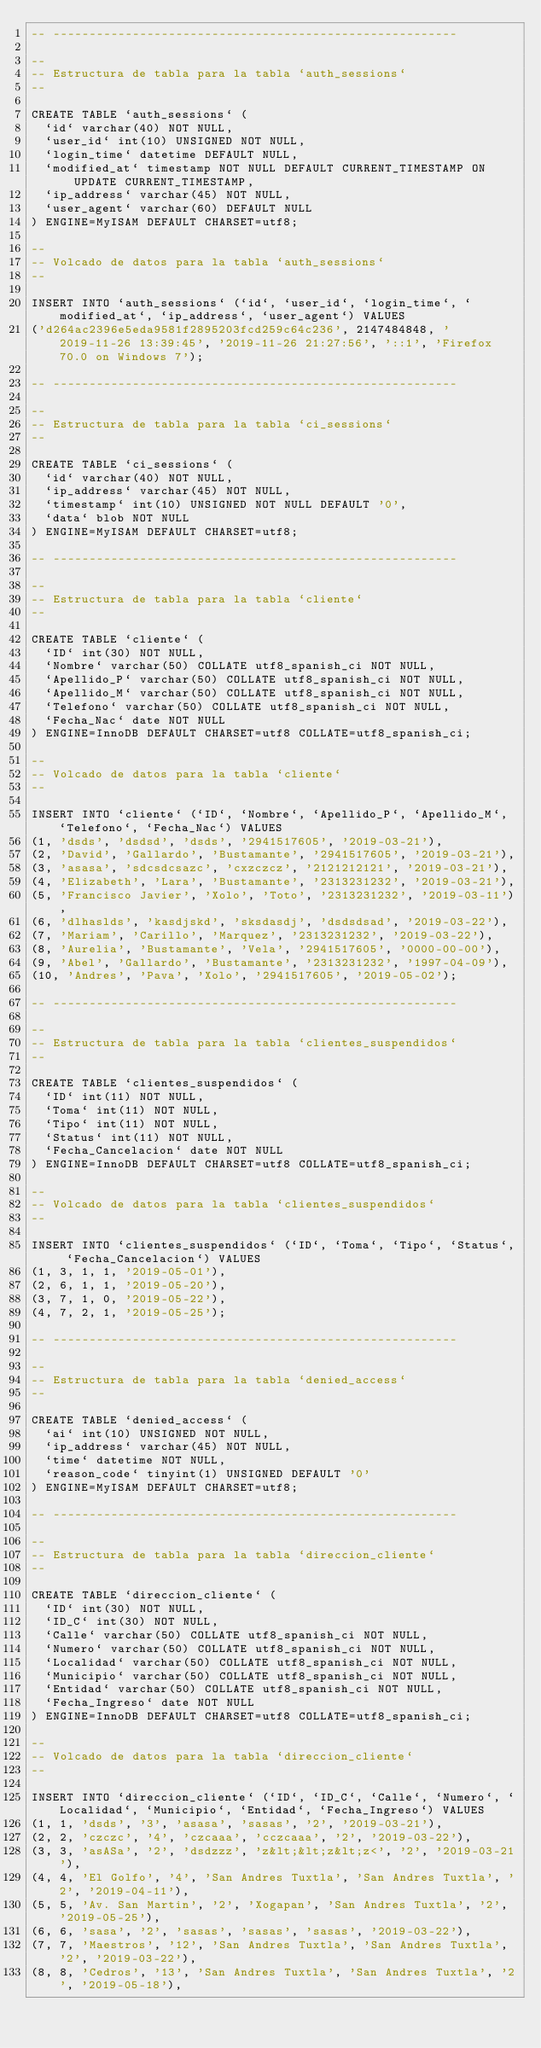Convert code to text. <code><loc_0><loc_0><loc_500><loc_500><_SQL_>-- --------------------------------------------------------

--
-- Estructura de tabla para la tabla `auth_sessions`
--

CREATE TABLE `auth_sessions` (
  `id` varchar(40) NOT NULL,
  `user_id` int(10) UNSIGNED NOT NULL,
  `login_time` datetime DEFAULT NULL,
  `modified_at` timestamp NOT NULL DEFAULT CURRENT_TIMESTAMP ON UPDATE CURRENT_TIMESTAMP,
  `ip_address` varchar(45) NOT NULL,
  `user_agent` varchar(60) DEFAULT NULL
) ENGINE=MyISAM DEFAULT CHARSET=utf8;

--
-- Volcado de datos para la tabla `auth_sessions`
--

INSERT INTO `auth_sessions` (`id`, `user_id`, `login_time`, `modified_at`, `ip_address`, `user_agent`) VALUES
('d264ac2396e5eda9581f2895203fcd259c64c236', 2147484848, '2019-11-26 13:39:45', '2019-11-26 21:27:56', '::1', 'Firefox 70.0 on Windows 7');

-- --------------------------------------------------------

--
-- Estructura de tabla para la tabla `ci_sessions`
--

CREATE TABLE `ci_sessions` (
  `id` varchar(40) NOT NULL,
  `ip_address` varchar(45) NOT NULL,
  `timestamp` int(10) UNSIGNED NOT NULL DEFAULT '0',
  `data` blob NOT NULL
) ENGINE=MyISAM DEFAULT CHARSET=utf8;

-- --------------------------------------------------------

--
-- Estructura de tabla para la tabla `cliente`
--

CREATE TABLE `cliente` (
  `ID` int(30) NOT NULL,
  `Nombre` varchar(50) COLLATE utf8_spanish_ci NOT NULL,
  `Apellido_P` varchar(50) COLLATE utf8_spanish_ci NOT NULL,
  `Apellido_M` varchar(50) COLLATE utf8_spanish_ci NOT NULL,
  `Telefono` varchar(50) COLLATE utf8_spanish_ci NOT NULL,
  `Fecha_Nac` date NOT NULL
) ENGINE=InnoDB DEFAULT CHARSET=utf8 COLLATE=utf8_spanish_ci;

--
-- Volcado de datos para la tabla `cliente`
--

INSERT INTO `cliente` (`ID`, `Nombre`, `Apellido_P`, `Apellido_M`, `Telefono`, `Fecha_Nac`) VALUES
(1, 'dsds', 'dsdsd', 'dsds', '2941517605', '2019-03-21'),
(2, 'David', 'Gallardo', 'Bustamante', '2941517605', '2019-03-21'),
(3, 'asasa', 'sdcsdcsazc', 'cxzczcz', '2121212121', '2019-03-21'),
(4, 'Elizabeth', 'Lara', 'Bustamante', '2313231232', '2019-03-21'),
(5, 'Francisco Javier', 'Xolo', 'Toto', '2313231232', '2019-03-11'),
(6, 'dlhaslds', 'kasdjskd', 'sksdasdj', 'dsdsdsad', '2019-03-22'),
(7, 'Mariam', 'Carillo', 'Marquez', '2313231232', '2019-03-22'),
(8, 'Aurelia', 'Bustamante', 'Vela', '2941517605', '0000-00-00'),
(9, 'Abel', 'Gallardo', 'Bustamante', '2313231232', '1997-04-09'),
(10, 'Andres', 'Pava', 'Xolo', '2941517605', '2019-05-02');

-- --------------------------------------------------------

--
-- Estructura de tabla para la tabla `clientes_suspendidos`
--

CREATE TABLE `clientes_suspendidos` (
  `ID` int(11) NOT NULL,
  `Toma` int(11) NOT NULL,
  `Tipo` int(11) NOT NULL,
  `Status` int(11) NOT NULL,
  `Fecha_Cancelacion` date NOT NULL
) ENGINE=InnoDB DEFAULT CHARSET=utf8 COLLATE=utf8_spanish_ci;

--
-- Volcado de datos para la tabla `clientes_suspendidos`
--

INSERT INTO `clientes_suspendidos` (`ID`, `Toma`, `Tipo`, `Status`, `Fecha_Cancelacion`) VALUES
(1, 3, 1, 1, '2019-05-01'),
(2, 6, 1, 1, '2019-05-20'),
(3, 7, 1, 0, '2019-05-22'),
(4, 7, 2, 1, '2019-05-25');

-- --------------------------------------------------------

--
-- Estructura de tabla para la tabla `denied_access`
--

CREATE TABLE `denied_access` (
  `ai` int(10) UNSIGNED NOT NULL,
  `ip_address` varchar(45) NOT NULL,
  `time` datetime NOT NULL,
  `reason_code` tinyint(1) UNSIGNED DEFAULT '0'
) ENGINE=MyISAM DEFAULT CHARSET=utf8;

-- --------------------------------------------------------

--
-- Estructura de tabla para la tabla `direccion_cliente`
--

CREATE TABLE `direccion_cliente` (
  `ID` int(30) NOT NULL,
  `ID_C` int(30) NOT NULL,
  `Calle` varchar(50) COLLATE utf8_spanish_ci NOT NULL,
  `Numero` varchar(50) COLLATE utf8_spanish_ci NOT NULL,
  `Localidad` varchar(50) COLLATE utf8_spanish_ci NOT NULL,
  `Municipio` varchar(50) COLLATE utf8_spanish_ci NOT NULL,
  `Entidad` varchar(50) COLLATE utf8_spanish_ci NOT NULL,
  `Fecha_Ingreso` date NOT NULL
) ENGINE=InnoDB DEFAULT CHARSET=utf8 COLLATE=utf8_spanish_ci;

--
-- Volcado de datos para la tabla `direccion_cliente`
--

INSERT INTO `direccion_cliente` (`ID`, `ID_C`, `Calle`, `Numero`, `Localidad`, `Municipio`, `Entidad`, `Fecha_Ingreso`) VALUES
(1, 1, 'dsds', '3', 'asasa', 'sasas', '2', '2019-03-21'),
(2, 2, 'czczc', '4', 'czcaaa', 'cczcaaa', '2', '2019-03-22'),
(3, 3, 'asASa', '2', 'dsdzzz', 'z&lt;&lt;z&lt;z<', '2', '2019-03-21'),
(4, 4, 'El Golfo', '4', 'San Andres Tuxtla', 'San Andres Tuxtla', '2', '2019-04-11'),
(5, 5, 'Av. San Martin', '2', 'Xogapan', 'San Andres Tuxtla', '2', '2019-05-25'),
(6, 6, 'sasa', '2', 'sasas', 'sasas', 'sasas', '2019-03-22'),
(7, 7, 'Maestros', '12', 'San Andres Tuxtla', 'San Andres Tuxtla', '2', '2019-03-22'),
(8, 8, 'Cedros', '13', 'San Andres Tuxtla', 'San Andres Tuxtla', '2', '2019-05-18'),</code> 